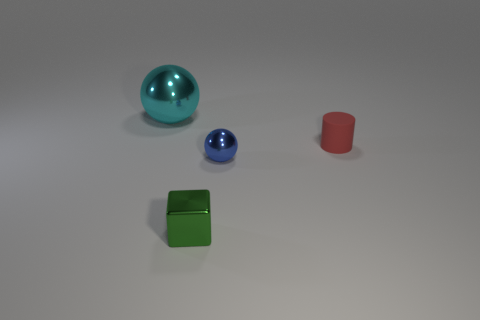Add 2 green rubber things. How many objects exist? 6 Subtract all brown cylinders. How many yellow balls are left? 0 Subtract all cylinders. Subtract all cyan shiny spheres. How many objects are left? 2 Add 3 tiny shiny things. How many tiny shiny things are left? 5 Add 4 blue shiny objects. How many blue shiny objects exist? 5 Subtract 0 red spheres. How many objects are left? 4 Subtract 1 cylinders. How many cylinders are left? 0 Subtract all yellow spheres. Subtract all red blocks. How many spheres are left? 2 